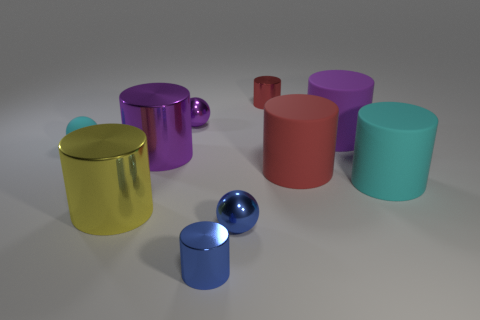What could be the possible uses for these objects based on their shapes and sizes? Based on their shapes and sizes, the cylindrical objects could be used as containers, vases, or storage, while the spherical ones might serve decorative purposes or could even be part of a children's playset. 